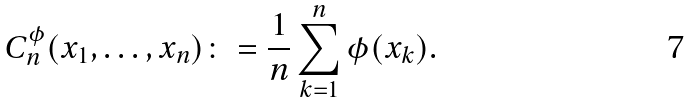<formula> <loc_0><loc_0><loc_500><loc_500>C _ { n } ^ { \phi } ( x _ { 1 } , \dots , x _ { n } ) \colon = \frac { 1 } { n } \sum _ { k = 1 } ^ { n } \phi ( x _ { k } ) .</formula> 